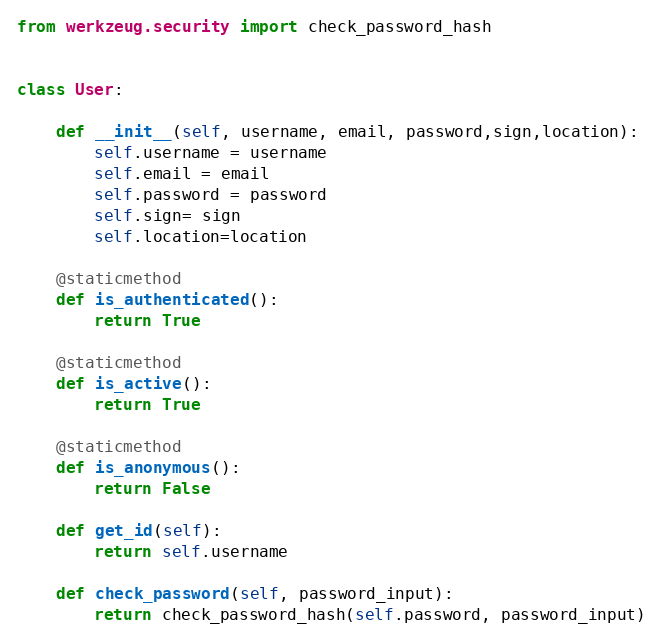Convert code to text. <code><loc_0><loc_0><loc_500><loc_500><_Python_>from werkzeug.security import check_password_hash


class User:

    def __init__(self, username, email, password,sign,location):
        self.username = username
        self.email = email
        self.password = password
        self.sign= sign
        self.location=location

    @staticmethod
    def is_authenticated():
        return True

    @staticmethod
    def is_active():
        return True

    @staticmethod
    def is_anonymous():
        return False

    def get_id(self):
        return self.username

    def check_password(self, password_input):
        return check_password_hash(self.password, password_input)
</code> 